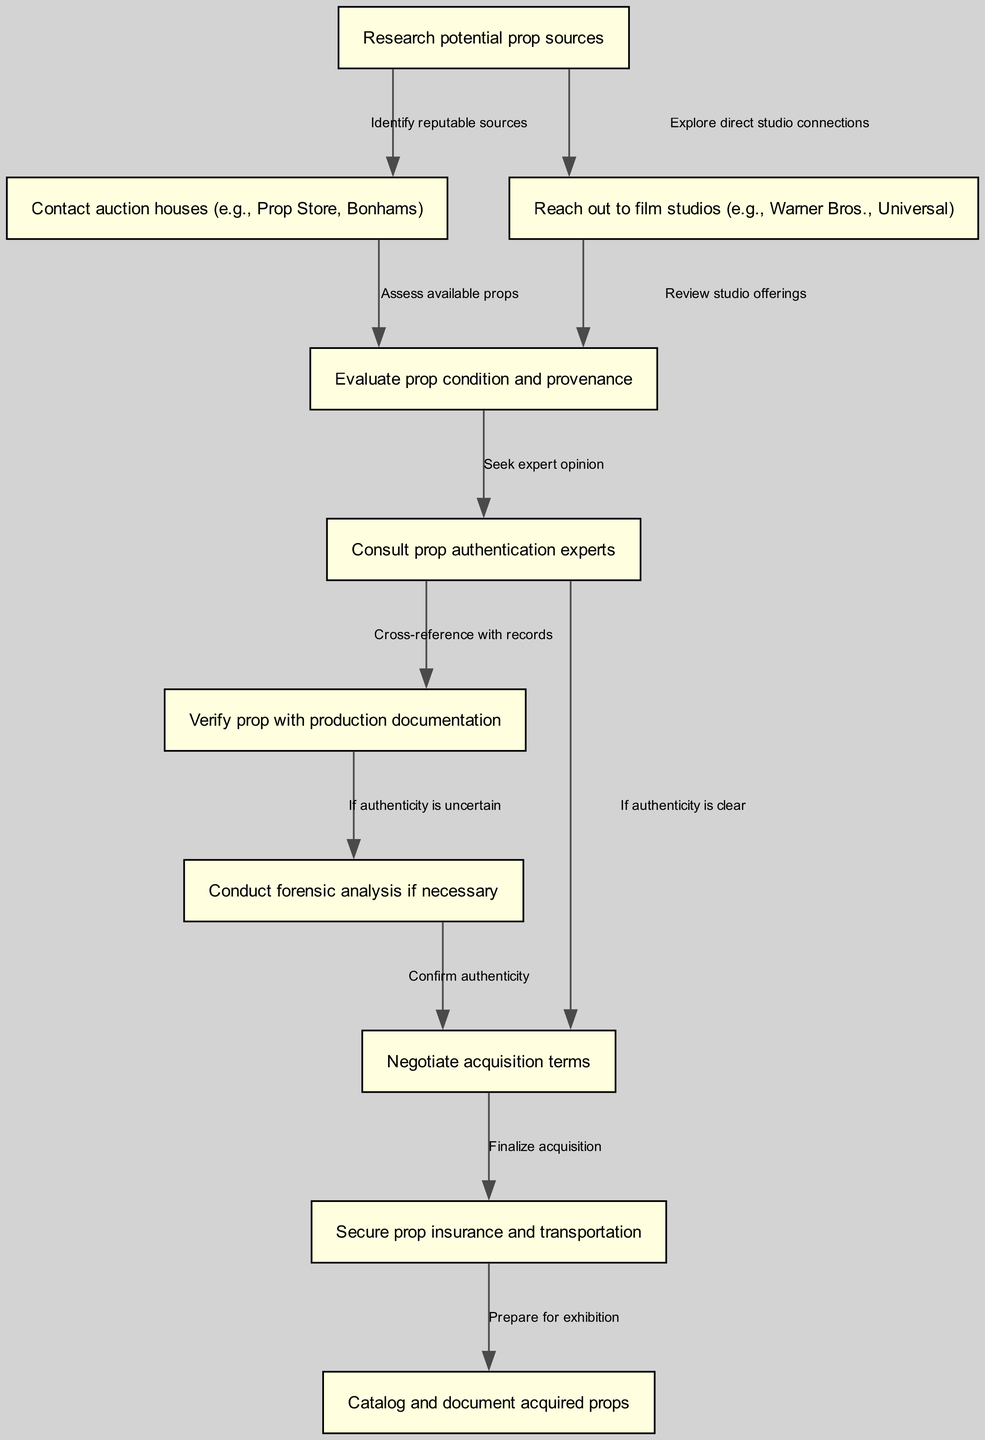What is the first step in the workflow? The first step is "Research potential prop sources," which is represented by the node with the identifier "1". This node does not have any preceding nodes on the diagram, indicating it is the starting point of the acquisition workflow.
Answer: Research potential prop sources How many nodes are in the diagram? The diagram contains a total of 10 distinct nodes, as listed in the data provided. Each node represents a specific step in the workflow.
Answer: 10 What type of nodes are connected by the edge labeled "Seek expert opinion"? The edge labeled "Seek expert opinion" connects the nodes "Evaluate prop condition and provenance" and "Consult prop authentication experts." This indicates a flow from assessing the condition of the props to seeking expert verification.
Answer: Evaluate prop condition and provenance and Consult prop authentication experts What follows after verifying a prop with production documentation? After the verification of a prop with production documentation (Step "6"), the next step is to "Conduct forensic analysis if necessary" (Step "7"). This means if the authenticity remains uncertain, further investigation is carried out.
Answer: Conduct forensic analysis if necessary Which step requires contacting auction houses? The node "Contact auction houses (e.g., Prop Store, Bonhams)" directly follows the node "Research potential prop sources." This indicates that contacting auction houses is essential after identifying potential sources for movie props.
Answer: Contact auction houses (e.g., Prop Store, Bonhams) What is the purpose of the "Negotiate acquisition terms" step? "Negotiate acquisition terms" involves finalizing details regarding the transaction after confirming authenticity. This step is crucial as it lays the groundwork for the legal acquisition of the props.
Answer: Finalize acquisition What happens if authenticity is unclear after consulting experts? If authenticity is unclear after consulting prop authentication experts (node "5"), the workflow directs to "Conduct forensic analysis if necessary" (node "7"). This indicates a methodical approach to ensure that unclear authenticity is scrutinized further before proceeding.
Answer: Conduct forensic analysis if necessary 